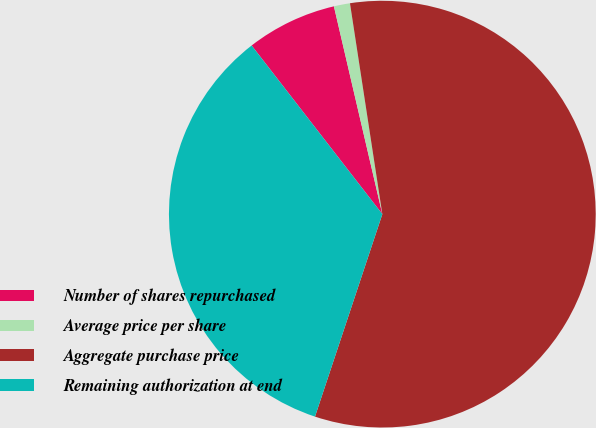<chart> <loc_0><loc_0><loc_500><loc_500><pie_chart><fcel>Number of shares repurchased<fcel>Average price per share<fcel>Aggregate purchase price<fcel>Remaining authorization at end<nl><fcel>6.85%<fcel>1.22%<fcel>57.54%<fcel>34.4%<nl></chart> 